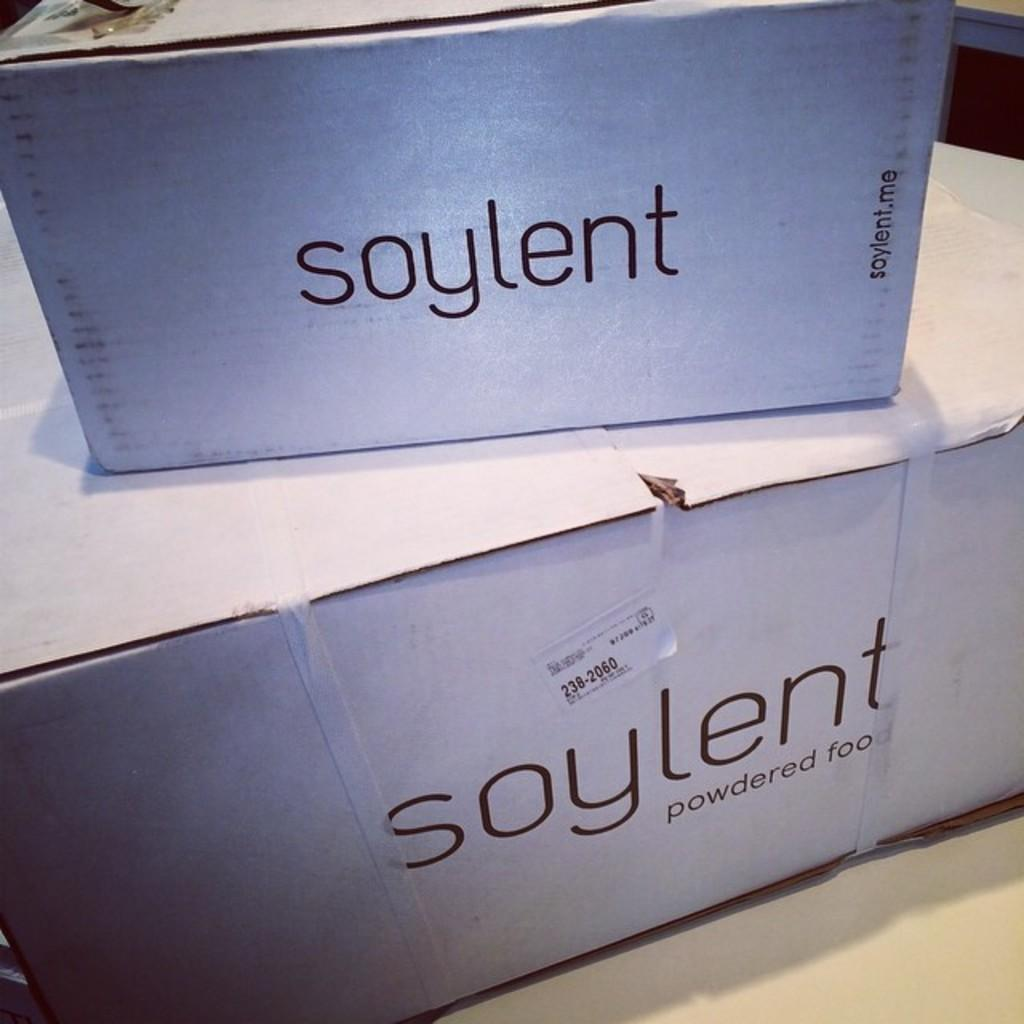<image>
Create a compact narrative representing the image presented. 2 stacked white boxes that say Soylent powdered food 